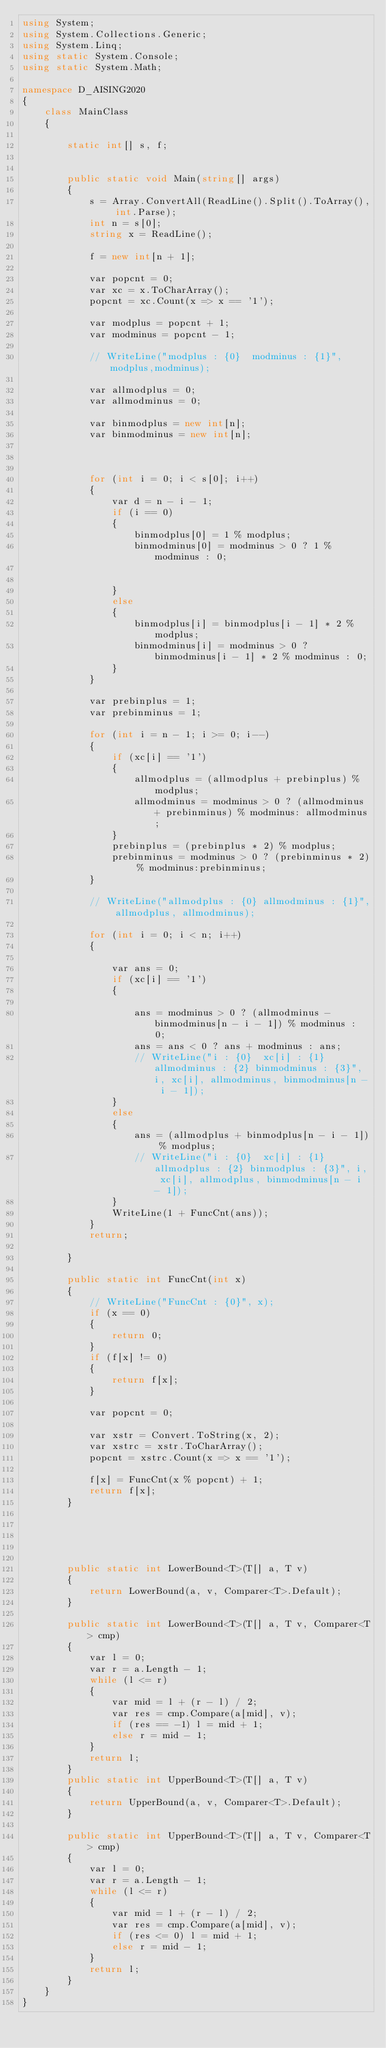Convert code to text. <code><loc_0><loc_0><loc_500><loc_500><_C#_>using System;
using System.Collections.Generic;
using System.Linq;
using static System.Console;
using static System.Math;

namespace D_AISING2020
{
    class MainClass
    {

        static int[] s, f;


        public static void Main(string[] args)
        {
            s = Array.ConvertAll(ReadLine().Split().ToArray(), int.Parse);
            int n = s[0];
            string x = ReadLine();

            f = new int[n + 1];

            var popcnt = 0;
            var xc = x.ToCharArray();
            popcnt = xc.Count(x => x == '1');

            var modplus = popcnt + 1;
            var modminus = popcnt - 1;

            // WriteLine("modplus : {0}  modminus : {1}",modplus,modminus);

            var allmodplus = 0;
            var allmodminus = 0;

            var binmodplus = new int[n];
            var binmodminus = new int[n];



            for (int i = 0; i < s[0]; i++)
            {
                var d = n - i - 1;
                if (i == 0)
                {
                    binmodplus[0] = 1 % modplus;
                    binmodminus[0] = modminus > 0 ? 1 % modminus : 0;


                }
                else
                {
                    binmodplus[i] = binmodplus[i - 1] * 2 % modplus;
                    binmodminus[i] = modminus > 0 ? binmodminus[i - 1] * 2 % modminus : 0;
                }
            }

            var prebinplus = 1;
            var prebinminus = 1;

            for (int i = n - 1; i >= 0; i--)
            {
                if (xc[i] == '1')
                {
                    allmodplus = (allmodplus + prebinplus) % modplus;
                    allmodminus = modminus > 0 ? (allmodminus + prebinminus) % modminus: allmodminus;
                }
                prebinplus = (prebinplus * 2) % modplus;
                prebinminus = modminus > 0 ? (prebinminus * 2) % modminus:prebinminus;
            }

            // WriteLine("allmodplus : {0} allmodminus : {1}", allmodplus, allmodminus);

            for (int i = 0; i < n; i++)
            {

                var ans = 0;
                if (xc[i] == '1')
                {

                    ans = modminus > 0 ? (allmodminus - binmodminus[n - i - 1]) % modminus : 0;
                    ans = ans < 0 ? ans + modminus : ans;
                    // WriteLine("i : {0}  xc[i] : {1} allmodminus : {2} binmodminus : {3}", i, xc[i], allmodminus, binmodminus[n - i - 1]);
                }
                else
                {
                    ans = (allmodplus + binmodplus[n - i - 1]) % modplus;
                    // WriteLine("i : {0}  xc[i] : {1} allmodplus : {2} binmodplus : {3}", i, xc[i], allmodplus, binmodminus[n - i - 1]);
                }
                WriteLine(1 + FuncCnt(ans));
            }
            return;

        }

        public static int FuncCnt(int x)
        {
            // WriteLine("FuncCnt : {0}", x);
            if (x == 0)
            {
                return 0;
            }
            if (f[x] != 0)
            {
                return f[x];
            }

            var popcnt = 0;

            var xstr = Convert.ToString(x, 2);
            var xstrc = xstr.ToCharArray();
            popcnt = xstrc.Count(x => x == '1');

            f[x] = FuncCnt(x % popcnt) + 1;
            return f[x];
        }





        public static int LowerBound<T>(T[] a, T v)
        {
            return LowerBound(a, v, Comparer<T>.Default);
        }

        public static int LowerBound<T>(T[] a, T v, Comparer<T> cmp)
        {
            var l = 0;
            var r = a.Length - 1;
            while (l <= r)
            {
                var mid = l + (r - l) / 2;
                var res = cmp.Compare(a[mid], v);
                if (res == -1) l = mid + 1;
                else r = mid - 1;
            }
            return l;
        }
        public static int UpperBound<T>(T[] a, T v)
        {
            return UpperBound(a, v, Comparer<T>.Default);
        }

        public static int UpperBound<T>(T[] a, T v, Comparer<T> cmp)
        {
            var l = 0;
            var r = a.Length - 1;
            while (l <= r)
            {
                var mid = l + (r - l) / 2;
                var res = cmp.Compare(a[mid], v);
                if (res <= 0) l = mid + 1;
                else r = mid - 1;
            }
            return l;
        }
    }
}
</code> 